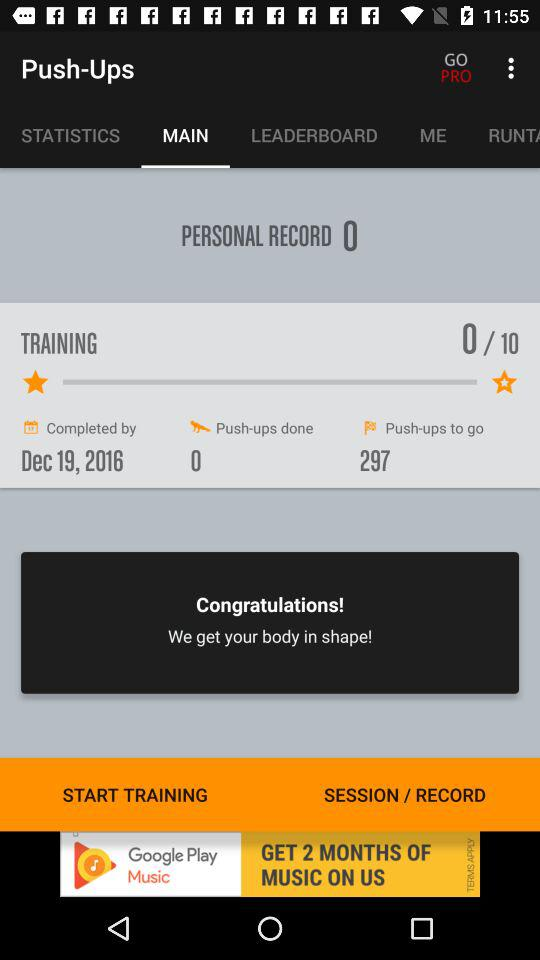How many more pushups do I have to do to beat my personal record?
Answer the question using a single word or phrase. 297 